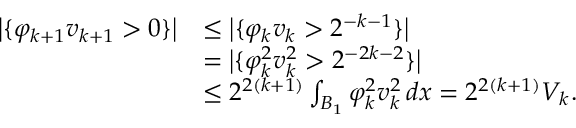<formula> <loc_0><loc_0><loc_500><loc_500>\begin{array} { r l } { \left | \{ \varphi _ { k + 1 } v _ { k + 1 } > 0 \} \right | } & { \leq \left | \{ \varphi _ { k } v _ { k } > 2 ^ { - k - 1 } \} \right | } \\ & { = \left | \{ \varphi _ { k } ^ { 2 } v _ { k } ^ { 2 } > 2 ^ { - 2 k - 2 } \} \right | } \\ & { \leq 2 ^ { 2 ( k + 1 ) } \int _ { B _ { 1 } } \varphi _ { k } ^ { 2 } v _ { k } ^ { 2 } \, d x = 2 ^ { 2 ( k + 1 ) } V _ { k } . } \end{array}</formula> 